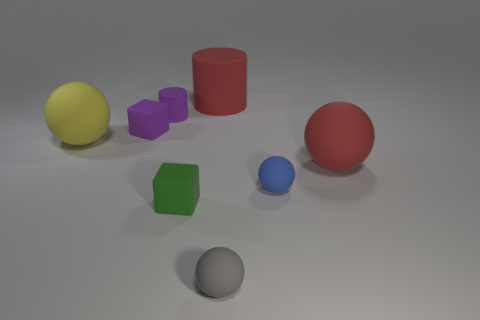Subtract 1 spheres. How many spheres are left? 3 Subtract all green spheres. Subtract all green cylinders. How many spheres are left? 4 Add 1 large red rubber cylinders. How many objects exist? 9 Subtract all cubes. How many objects are left? 6 Add 3 brown matte cubes. How many brown matte cubes exist? 3 Subtract 0 green spheres. How many objects are left? 8 Subtract all big matte things. Subtract all small rubber objects. How many objects are left? 0 Add 6 tiny cylinders. How many tiny cylinders are left? 7 